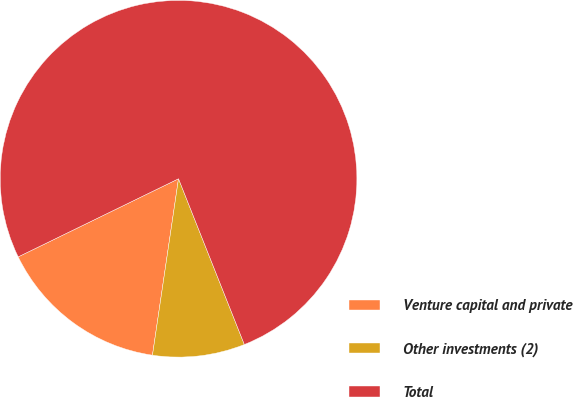Convert chart. <chart><loc_0><loc_0><loc_500><loc_500><pie_chart><fcel>Venture capital and private<fcel>Other investments (2)<fcel>Total<nl><fcel>15.45%<fcel>8.35%<fcel>76.2%<nl></chart> 